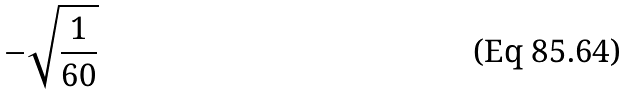<formula> <loc_0><loc_0><loc_500><loc_500>- \sqrt { \frac { 1 } { 6 0 } }</formula> 